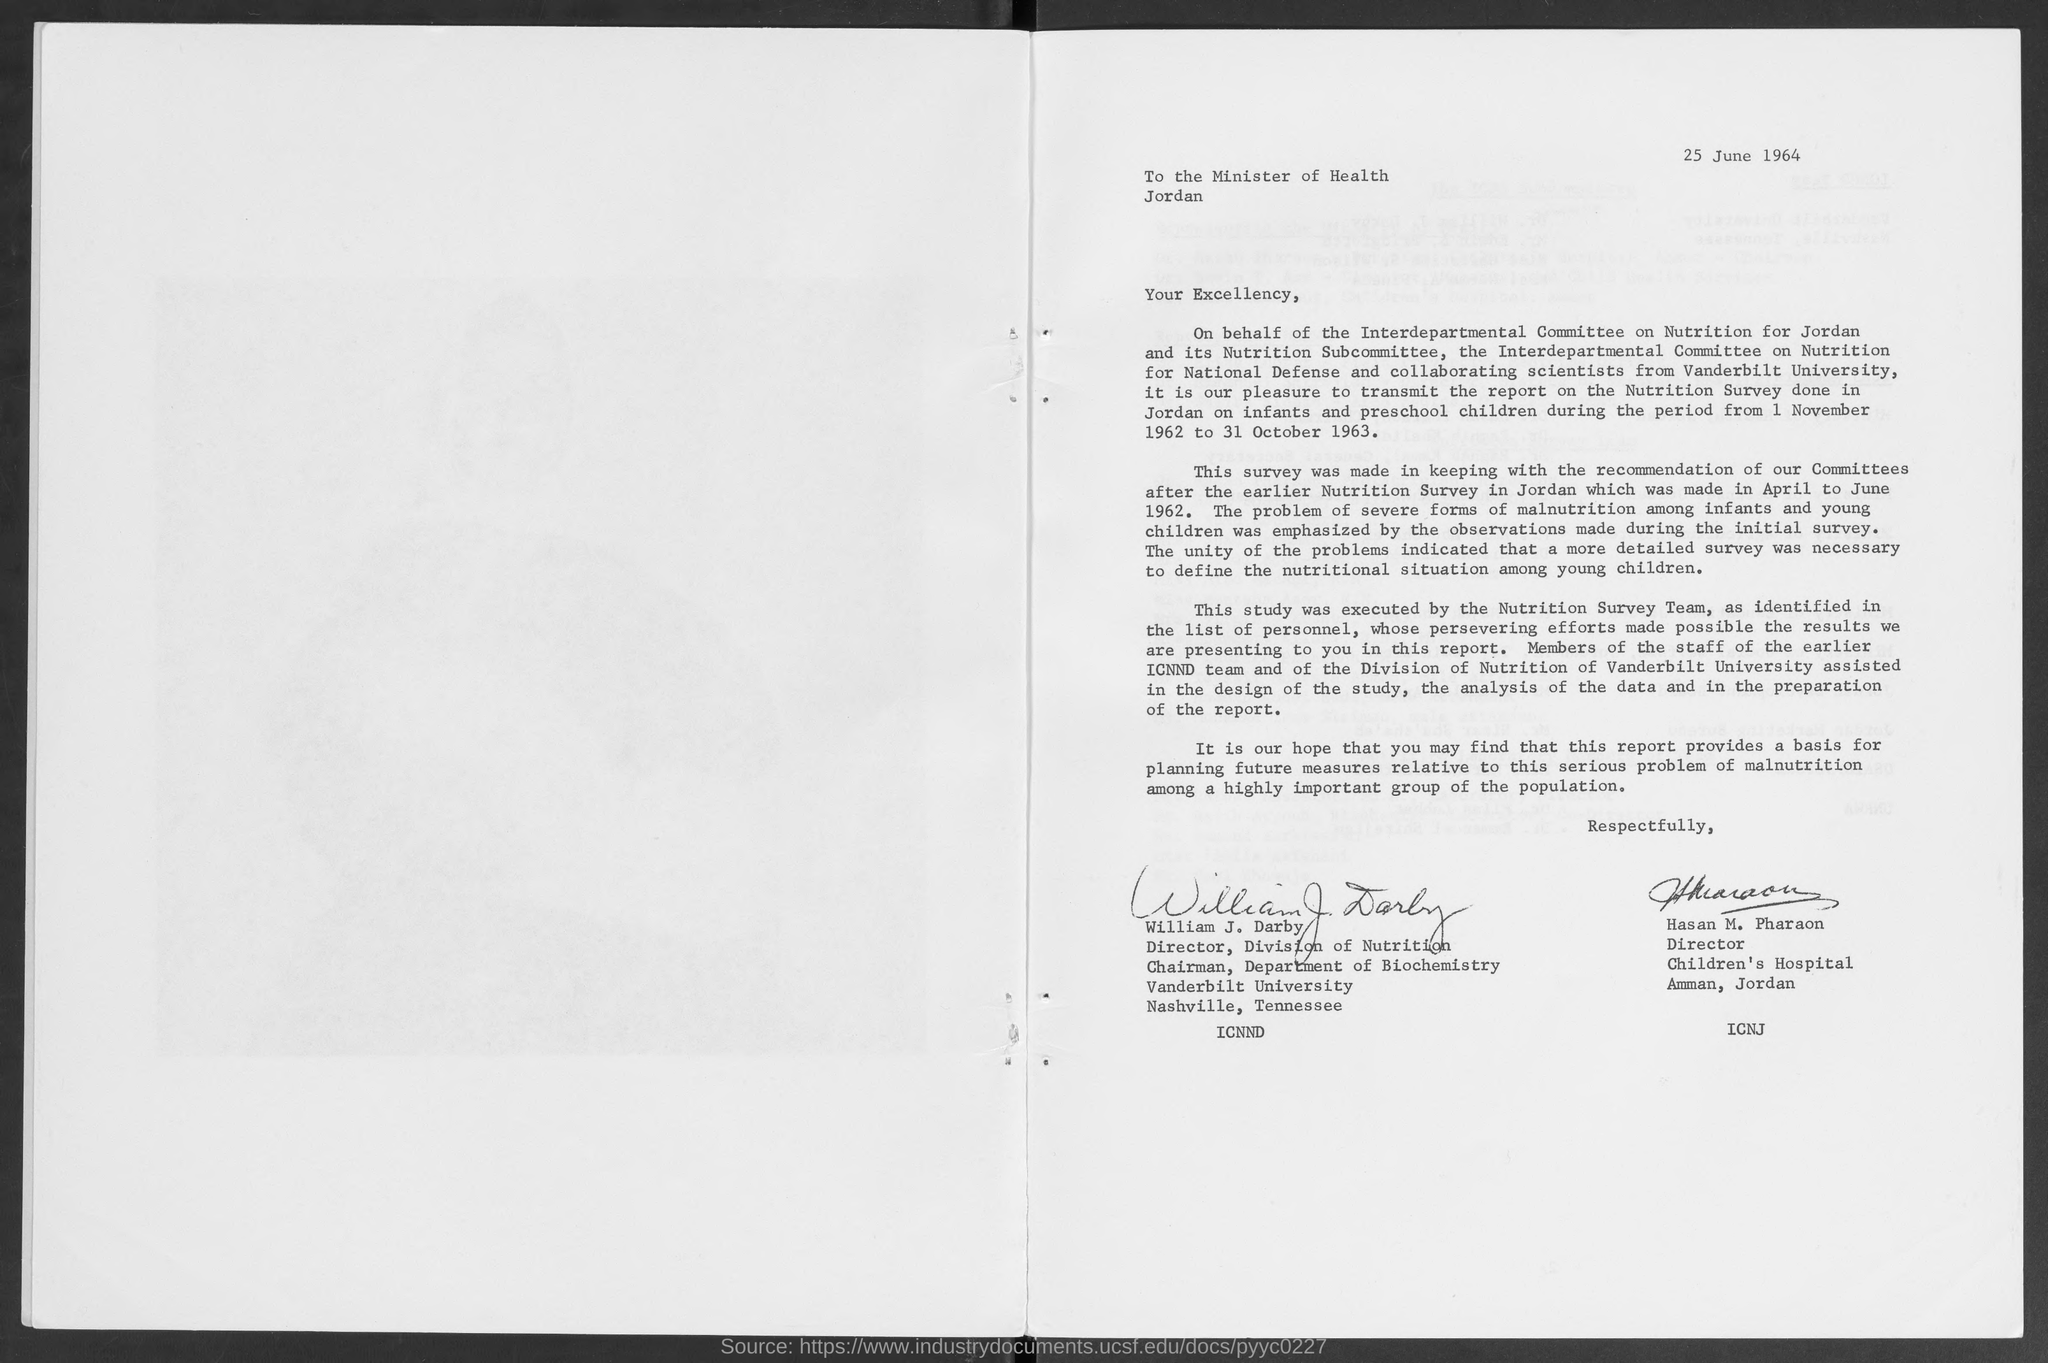What is the issued date of this letter?
Offer a terse response. 25 June 1964. Who is the Director, Division of Nutrition?
Provide a short and direct response. William J. Darby. 